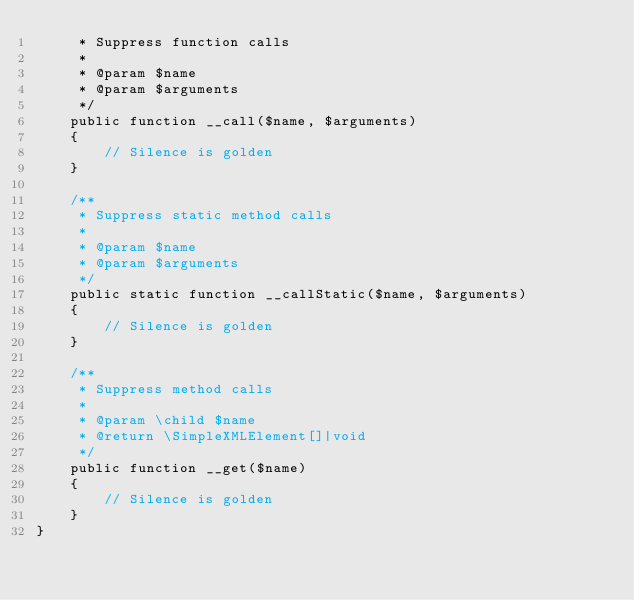<code> <loc_0><loc_0><loc_500><loc_500><_PHP_>     * Suppress function calls
     *
     * @param $name
     * @param $arguments
     */
    public function __call($name, $arguments)
    {
        // Silence is golden
    }

    /**
     * Suppress static method calls
     *
     * @param $name
     * @param $arguments
     */
    public static function __callStatic($name, $arguments)
    {
        // Silence is golden
    }

    /**
     * Suppress method calls
     *
     * @param \child $name
     * @return \SimpleXMLElement[]|void
     */
    public function __get($name)
    {
        // Silence is golden
    }
}</code> 